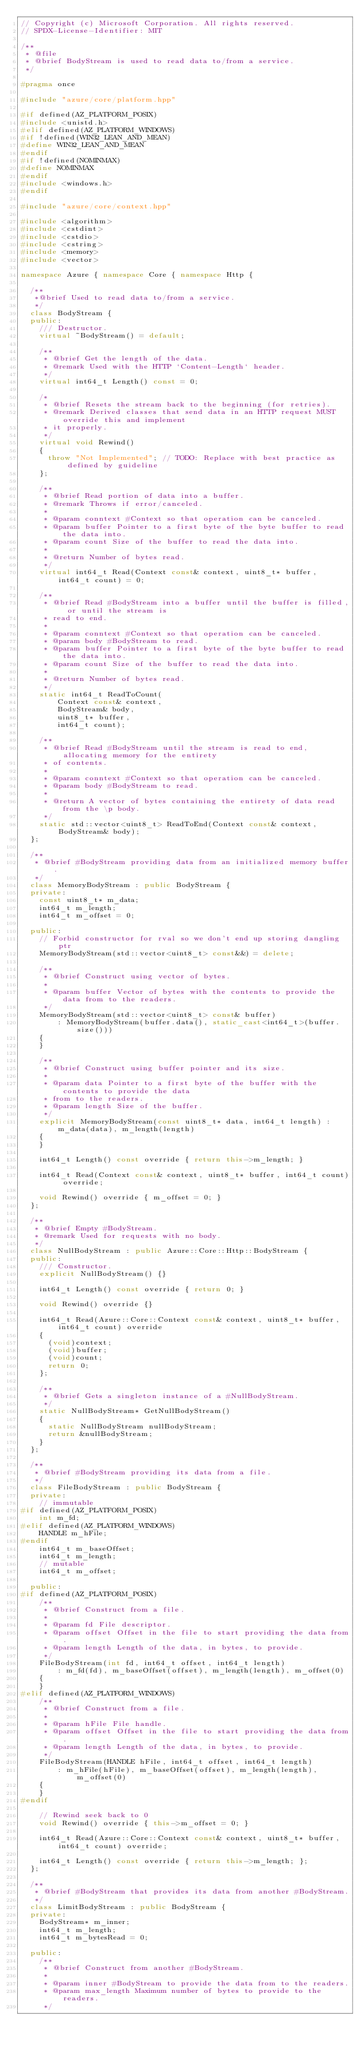Convert code to text. <code><loc_0><loc_0><loc_500><loc_500><_C++_>// Copyright (c) Microsoft Corporation. All rights reserved.
// SPDX-License-Identifier: MIT

/**
 * @file
 * @brief BodyStream is used to read data to/from a service.
 */

#pragma once

#include "azure/core/platform.hpp"

#if defined(AZ_PLATFORM_POSIX)
#include <unistd.h>
#elif defined(AZ_PLATFORM_WINDOWS)
#if !defined(WIN32_LEAN_AND_MEAN)
#define WIN32_LEAN_AND_MEAN
#endif
#if !defined(NOMINMAX)
#define NOMINMAX
#endif
#include <windows.h>
#endif

#include "azure/core/context.hpp"

#include <algorithm>
#include <cstdint>
#include <cstdio>
#include <cstring>
#include <memory>
#include <vector>

namespace Azure { namespace Core { namespace Http {

  /**
   *@brief Used to read data to/from a service.
   */
  class BodyStream {
  public:
    /// Destructor.
    virtual ~BodyStream() = default;

    /**
     * @brief Get the length of the data.
     * @remark Used with the HTTP `Content-Length` header.
     */
    virtual int64_t Length() const = 0;

    /*
     * @brief Resets the stream back to the beginning (for retries).
     * @remark Derived classes that send data in an HTTP request MUST override this and implement
     * it properly.
     */
    virtual void Rewind()
    {
      throw "Not Implemented"; // TODO: Replace with best practice as defined by guideline
    };

    /**
     * @brief Read portion of data into a buffer.
     * @remark Throws if error/canceled.
     *
     * @param conntext #Context so that operation can be canceled.
     * @param buffer Pointer to a first byte of the byte buffer to read the data into.
     * @param count Size of the buffer to read the data into.
     *
     * @return Number of bytes read.
     */
    virtual int64_t Read(Context const& context, uint8_t* buffer, int64_t count) = 0;

    /**
     * @brief Read #BodyStream into a buffer until the buffer is filled, or until the stream is
     * read to end.
     *
     * @param conntext #Context so that operation can be canceled.
     * @param body #BodyStream to read.
     * @param buffer Pointer to a first byte of the byte buffer to read the data into.
     * @param count Size of the buffer to read the data into.
     *
     * @return Number of bytes read.
     */
    static int64_t ReadToCount(
        Context const& context,
        BodyStream& body,
        uint8_t* buffer,
        int64_t count);

    /**
     * @brief Read #BodyStream until the stream is read to end, allocating memory for the entirety
     * of contents.
     *
     * @param conntext #Context so that operation can be canceled.
     * @param body #BodyStream to read.
     *
     * @return A vector of bytes containing the entirety of data read from the \p body.
     */
    static std::vector<uint8_t> ReadToEnd(Context const& context, BodyStream& body);
  };

  /**
   * @brief #BodyStream providing data from an initialized memory buffer.
   */
  class MemoryBodyStream : public BodyStream {
  private:
    const uint8_t* m_data;
    int64_t m_length;
    int64_t m_offset = 0;

  public:
    // Forbid constructor for rval so we don't end up storing dangling ptr
    MemoryBodyStream(std::vector<uint8_t> const&&) = delete;

    /**
     * @brief Construct using vector of bytes.
     *
     * @param buffer Vector of bytes with the contents to provide the data from to the readers.
     */
    MemoryBodyStream(std::vector<uint8_t> const& buffer)
        : MemoryBodyStream(buffer.data(), static_cast<int64_t>(buffer.size()))
    {
    }

    /**
     * @brief Construct using buffer pointer and its size.
     *
     * @param data Pointer to a first byte of the buffer with the contents to provide the data
     * from to the readers.
     * @param length Size of the buffer.
     */
    explicit MemoryBodyStream(const uint8_t* data, int64_t length) : m_data(data), m_length(length)
    {
    }

    int64_t Length() const override { return this->m_length; }

    int64_t Read(Context const& context, uint8_t* buffer, int64_t count) override;

    void Rewind() override { m_offset = 0; }
  };

  /**
   * @brief Empty #BodyStream.
   * @remark Used for requests with no body.
   */
  class NullBodyStream : public Azure::Core::Http::BodyStream {
  public:
    /// Constructor.
    explicit NullBodyStream() {}

    int64_t Length() const override { return 0; }

    void Rewind() override {}

    int64_t Read(Azure::Core::Context const& context, uint8_t* buffer, int64_t count) override
    {
      (void)context;
      (void)buffer;
      (void)count;
      return 0;
    };

    /**
     * @brief Gets a singleton instance of a #NullBodyStream.
     */
    static NullBodyStream* GetNullBodyStream()
    {
      static NullBodyStream nullBodyStream;
      return &nullBodyStream;
    }
  };

  /**
   * @brief #BodyStream providing its data from a file.
   */
  class FileBodyStream : public BodyStream {
  private:
    // immutable
#if defined(AZ_PLATFORM_POSIX)
    int m_fd;
#elif defined(AZ_PLATFORM_WINDOWS)
    HANDLE m_hFile;
#endif
    int64_t m_baseOffset;
    int64_t m_length;
    // mutable
    int64_t m_offset;

  public:
#if defined(AZ_PLATFORM_POSIX)
    /**
     * @brief Construct from a file.
     *
     * @param fd File descriptor.
     * @param offset Offset in the file to start providing the data from.
     * @param length Length of the data, in bytes, to provide.
     */
    FileBodyStream(int fd, int64_t offset, int64_t length)
        : m_fd(fd), m_baseOffset(offset), m_length(length), m_offset(0)
    {
    }
#elif defined(AZ_PLATFORM_WINDOWS)
    /**
     * @brief Construct from a file.
     *
     * @param hFile File handle.
     * @param offset Offset in the file to start providing the data from.
     * @param length Length of the data, in bytes, to provide.
     */
    FileBodyStream(HANDLE hFile, int64_t offset, int64_t length)
        : m_hFile(hFile), m_baseOffset(offset), m_length(length), m_offset(0)
    {
    }
#endif

    // Rewind seek back to 0
    void Rewind() override { this->m_offset = 0; }

    int64_t Read(Azure::Core::Context const& context, uint8_t* buffer, int64_t count) override;

    int64_t Length() const override { return this->m_length; };
  };

  /**
   * @brief #BodyStream that provides its data from another #BodyStream.
   */
  class LimitBodyStream : public BodyStream {
  private:
    BodyStream* m_inner;
    int64_t m_length;
    int64_t m_bytesRead = 0;

  public:
    /**
     * @brief Construct from another #BodyStream.
     *
     * @param inner #BodyStream to provide the data from to the readers.
     * @param max_length Maximum number of bytes to provide to the readers.
     */</code> 